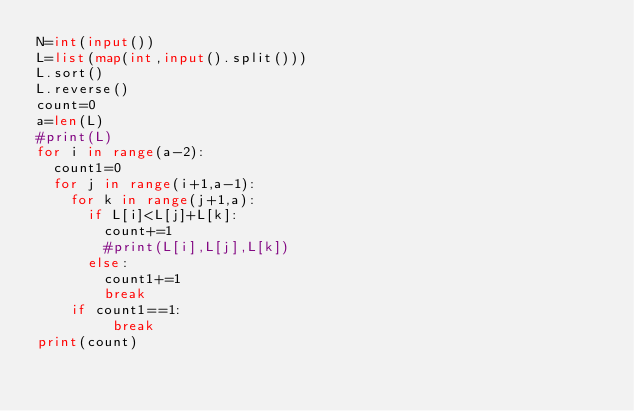Convert code to text. <code><loc_0><loc_0><loc_500><loc_500><_Python_>N=int(input())
L=list(map(int,input().split()))
L.sort()
L.reverse()
count=0
a=len(L)
#print(L)
for i in range(a-2):
  count1=0
  for j in range(i+1,a-1):
    for k in range(j+1,a):
      if L[i]<L[j]+L[k]:
        count+=1
        #print(L[i],L[j],L[k])
      else:
        count1+=1
        break
    if count1==1:
         break
print(count)</code> 